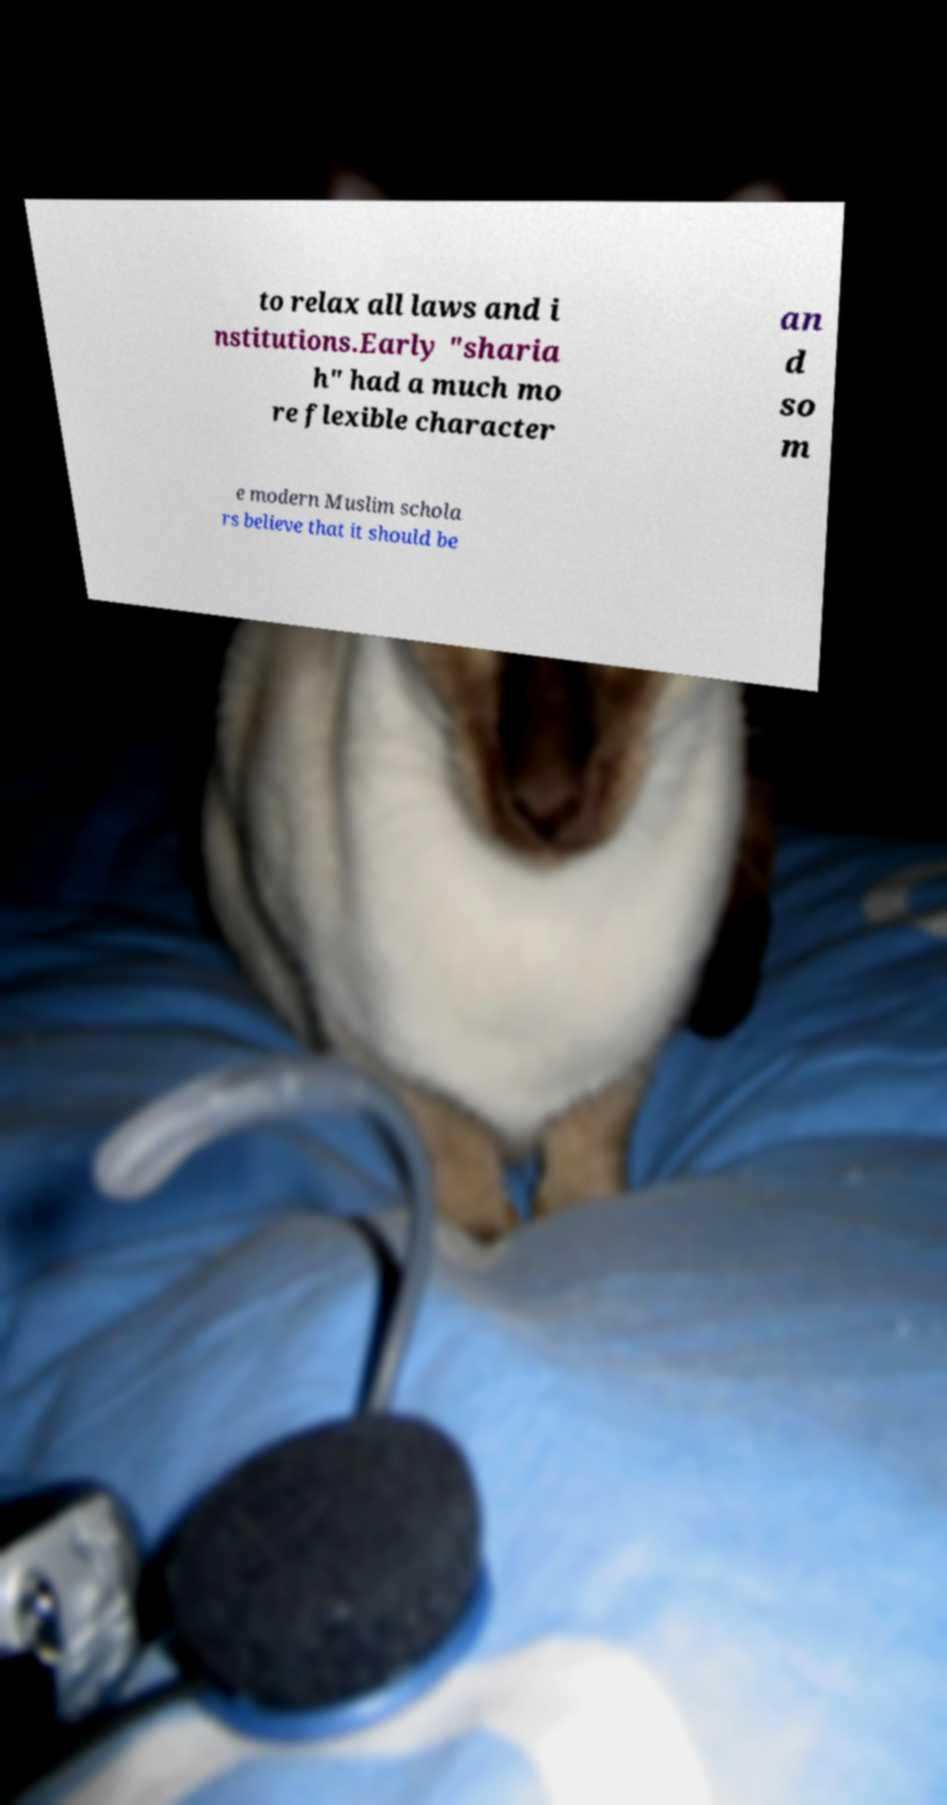Can you read and provide the text displayed in the image?This photo seems to have some interesting text. Can you extract and type it out for me? to relax all laws and i nstitutions.Early "sharia h" had a much mo re flexible character an d so m e modern Muslim schola rs believe that it should be 